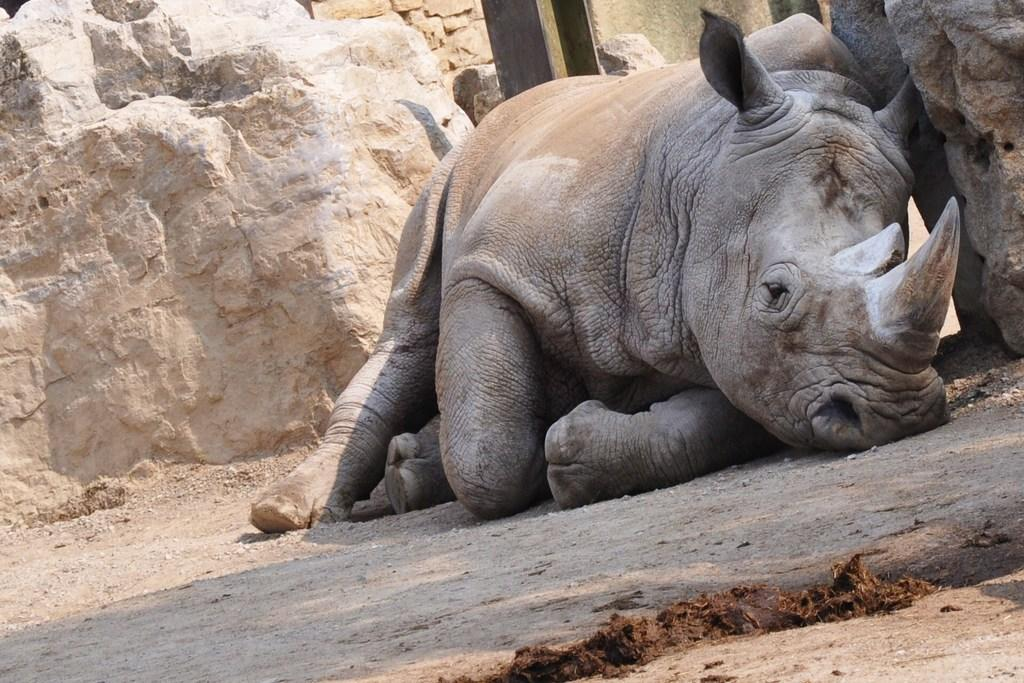What animal is present in the image? There is a rhinoceros in the image. What type of natural formation can be seen in the image? There are rocks in the image. What type of street can be seen in the image? There is no street present in the image; it features a rhinoceros and rocks. How many quivers are visible in the image? There are no quivers present in the image. 